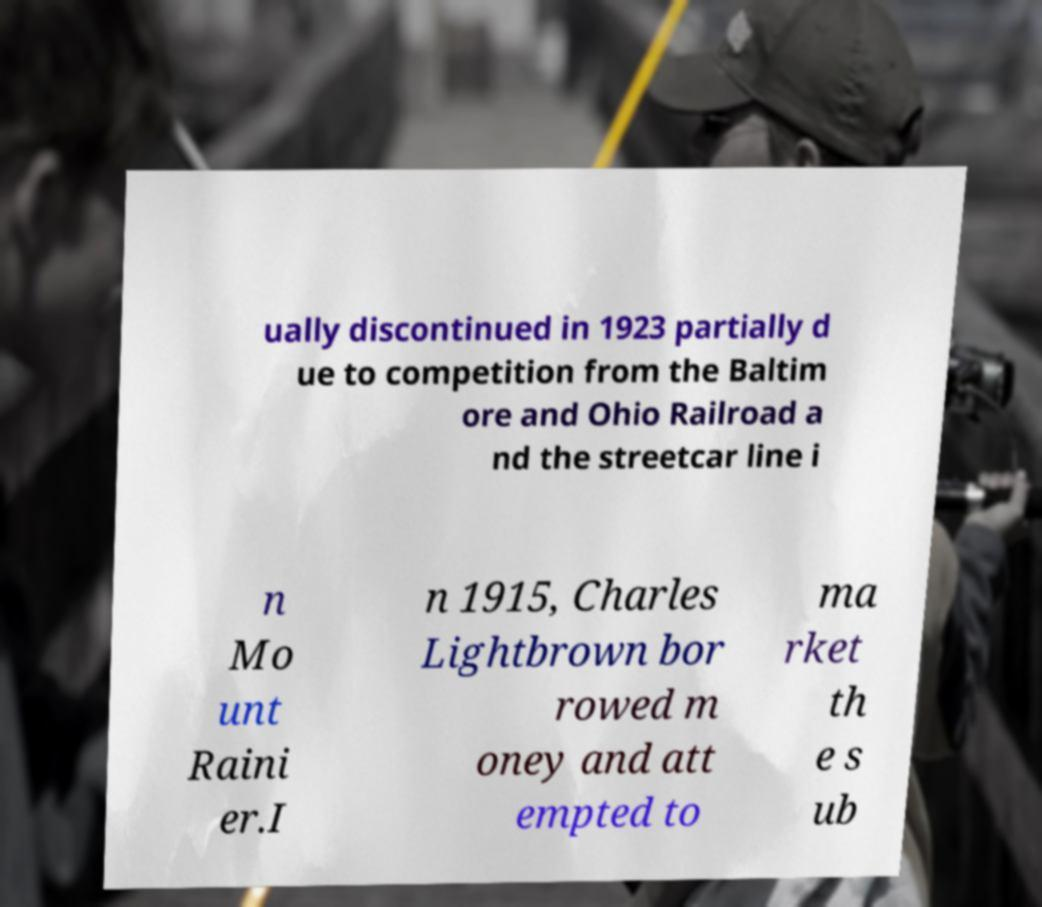What messages or text are displayed in this image? I need them in a readable, typed format. ually discontinued in 1923 partially d ue to competition from the Baltim ore and Ohio Railroad a nd the streetcar line i n Mo unt Raini er.I n 1915, Charles Lightbrown bor rowed m oney and att empted to ma rket th e s ub 